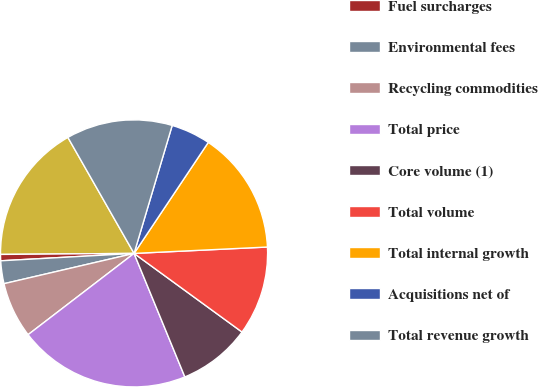Convert chart to OTSL. <chart><loc_0><loc_0><loc_500><loc_500><pie_chart><fcel>Core price<fcel>Fuel surcharges<fcel>Environmental fees<fcel>Recycling commodities<fcel>Total price<fcel>Core volume (1)<fcel>Total volume<fcel>Total internal growth<fcel>Acquisitions net of<fcel>Total revenue growth<nl><fcel>16.87%<fcel>0.76%<fcel>2.76%<fcel>6.77%<fcel>20.8%<fcel>8.77%<fcel>10.78%<fcel>14.86%<fcel>4.77%<fcel>12.86%<nl></chart> 